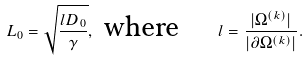<formula> <loc_0><loc_0><loc_500><loc_500>L _ { 0 } = \sqrt { \frac { l D _ { 0 } } { \gamma } } , \text { where } \quad l = \frac { | \Omega ^ { ( k ) } | } { | \partial \Omega ^ { ( k ) } | } .</formula> 